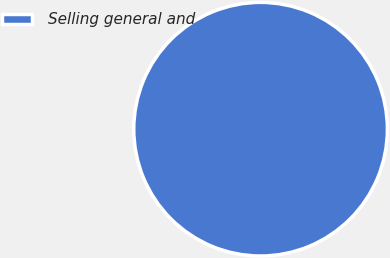<chart> <loc_0><loc_0><loc_500><loc_500><pie_chart><fcel>Selling general and<nl><fcel>100.0%<nl></chart> 